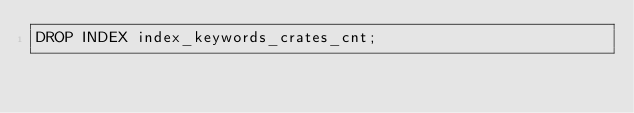<code> <loc_0><loc_0><loc_500><loc_500><_SQL_>DROP INDEX index_keywords_crates_cnt;</code> 